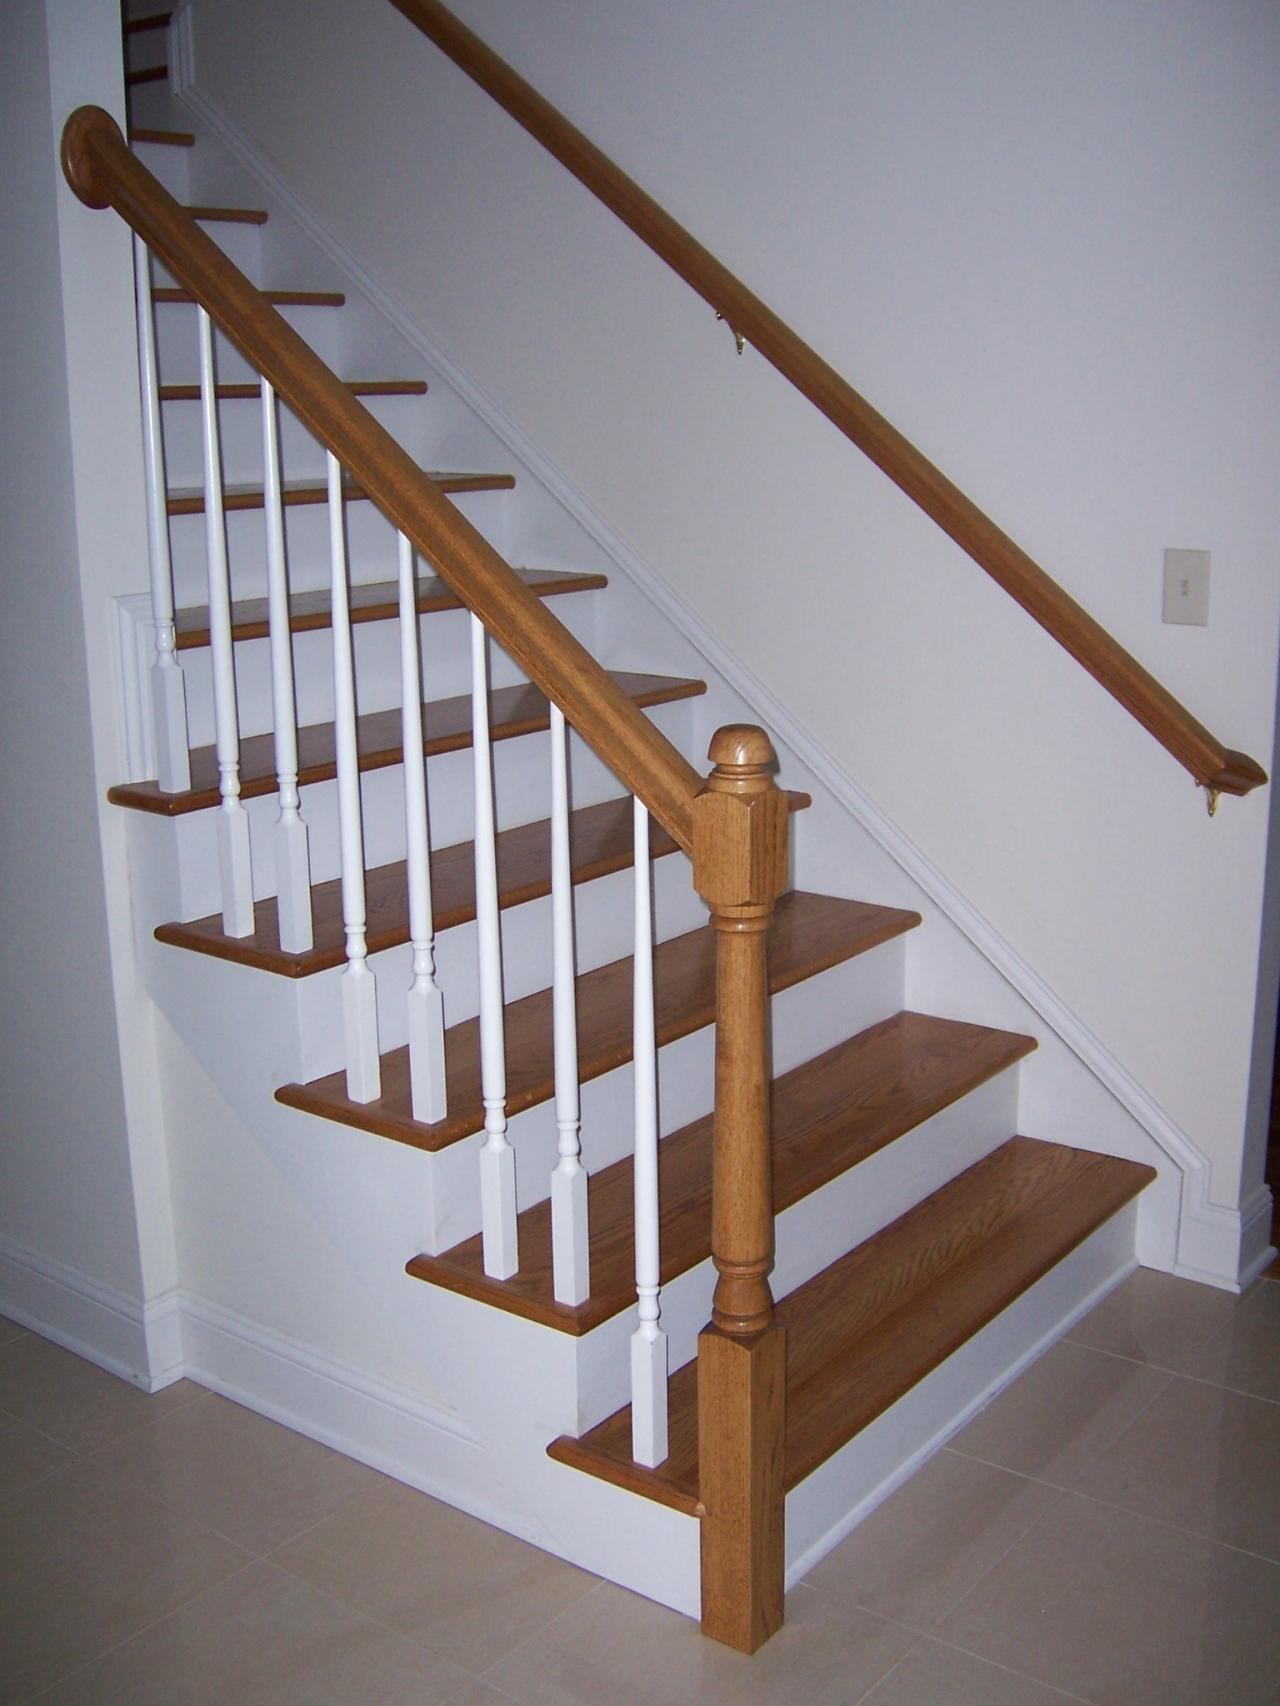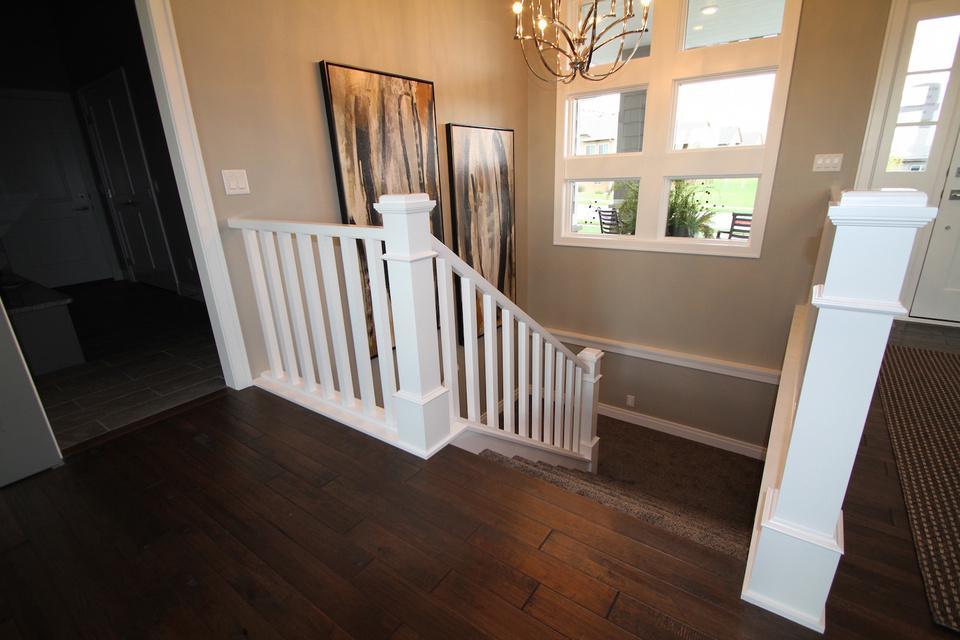The first image is the image on the left, the second image is the image on the right. Examine the images to the left and right. Is the description "there is a srairway being shown from the top floor, the rails are white and the top rail is painted black" accurate? Answer yes or no. No. The first image is the image on the left, the second image is the image on the right. For the images shown, is this caption "In one image, at least one newel post is at the bottom of stairs, but in the second image, two newel posts are at the top of stairs." true? Answer yes or no. Yes. 